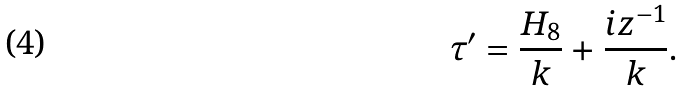<formula> <loc_0><loc_0><loc_500><loc_500>\tau ^ { \prime } = \frac { H _ { 8 } } { k } + \frac { i z ^ { - 1 } } { k } .</formula> 